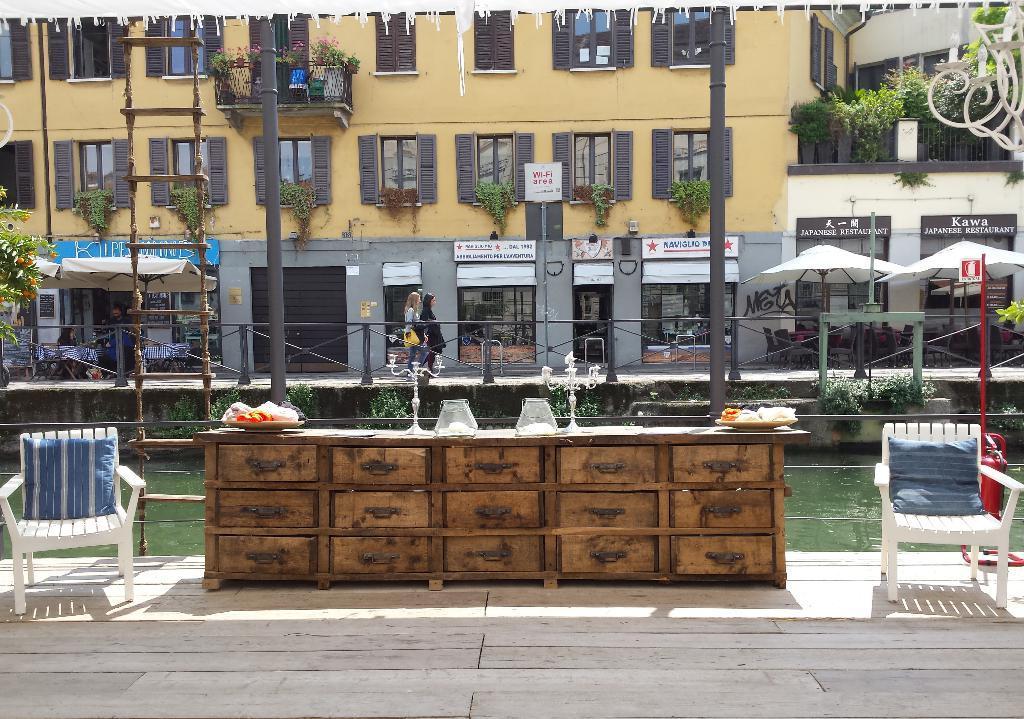Please provide a concise description of this image. This picture shows a building and few plants and a couple of umbrellas and a canal and a table and two chairs 